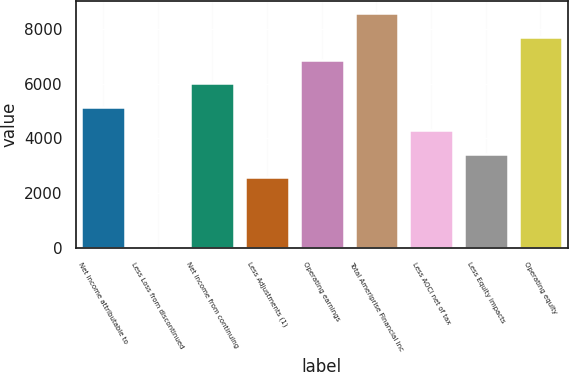Convert chart to OTSL. <chart><loc_0><loc_0><loc_500><loc_500><bar_chart><fcel>Net income attributable to<fcel>Less Loss from discontinued<fcel>Net income from continuing<fcel>Less Adjustments (1)<fcel>Operating earnings<fcel>Total Ameriprise Financial Inc<fcel>Less AOCI net of tax<fcel>Less Equity impacts<fcel>Operating equity<nl><fcel>5150.4<fcel>3<fcel>6008.3<fcel>2576.7<fcel>6866.2<fcel>8582<fcel>4292.5<fcel>3434.6<fcel>7724.1<nl></chart> 